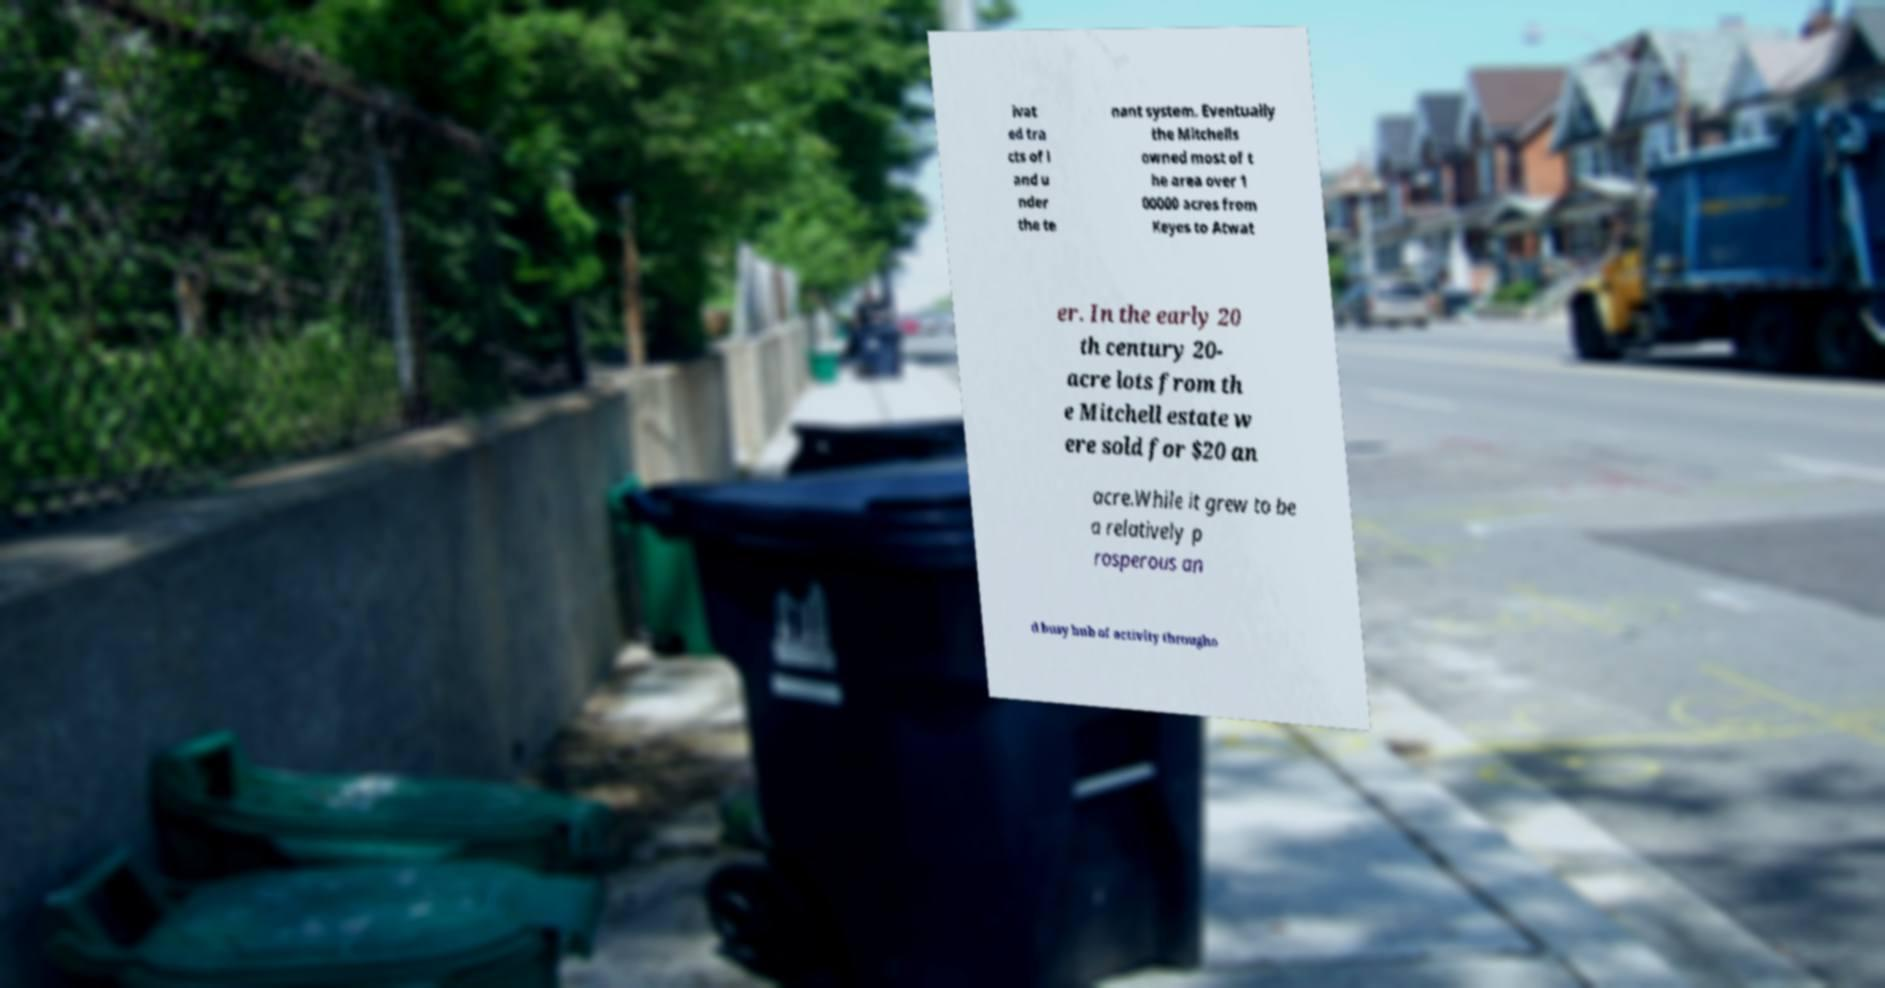Can you accurately transcribe the text from the provided image for me? ivat ed tra cts of l and u nder the te nant system. Eventually the Mitchells owned most of t he area over 1 00000 acres from Keyes to Atwat er. In the early 20 th century 20- acre lots from th e Mitchell estate w ere sold for $20 an acre.While it grew to be a relatively p rosperous an d busy hub of activity througho 